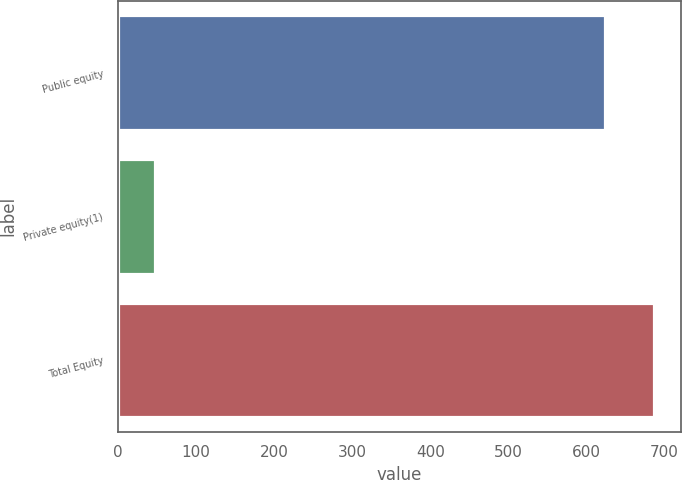Convert chart to OTSL. <chart><loc_0><loc_0><loc_500><loc_500><bar_chart><fcel>Public equity<fcel>Private equity(1)<fcel>Total Equity<nl><fcel>624<fcel>48<fcel>686.4<nl></chart> 